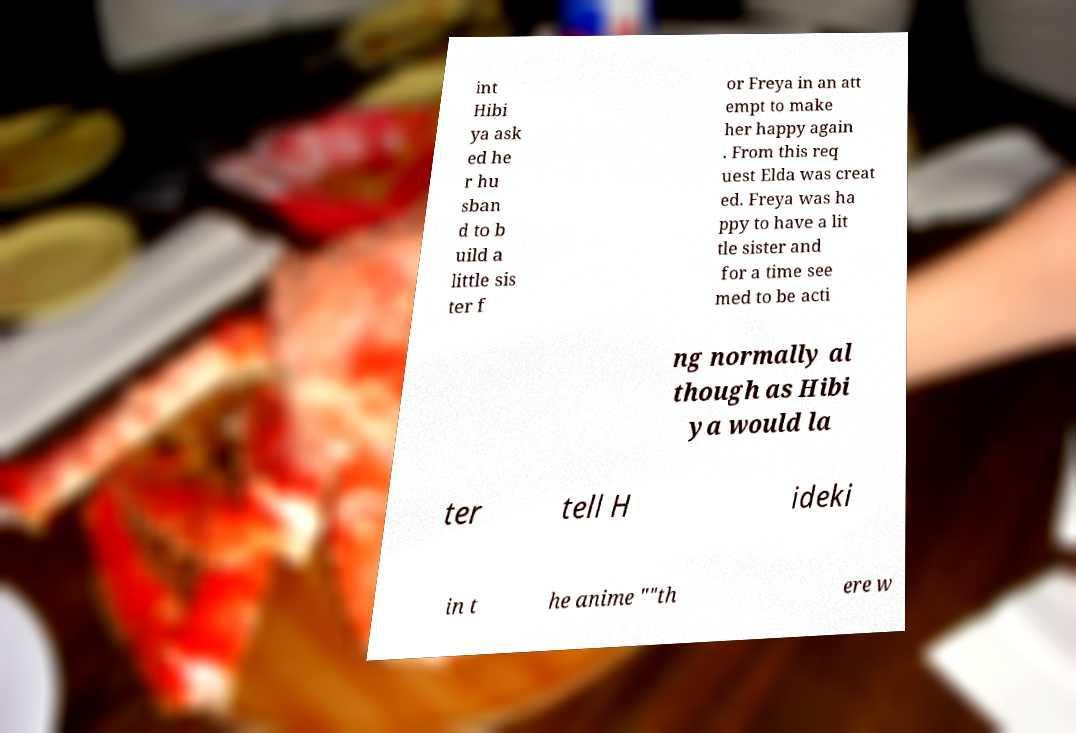Could you extract and type out the text from this image? int Hibi ya ask ed he r hu sban d to b uild a little sis ter f or Freya in an att empt to make her happy again . From this req uest Elda was creat ed. Freya was ha ppy to have a lit tle sister and for a time see med to be acti ng normally al though as Hibi ya would la ter tell H ideki in t he anime ""th ere w 